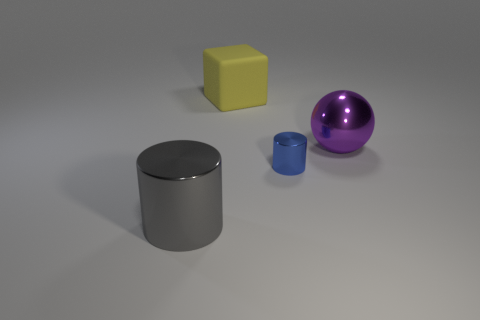Subtract all blue cylinders. How many cylinders are left? 1 Add 2 big yellow rubber objects. How many objects exist? 6 Subtract 0 brown blocks. How many objects are left? 4 Subtract all spheres. How many objects are left? 3 Subtract all gray cylinders. Subtract all green blocks. How many cylinders are left? 1 Subtract all purple spheres. How many blue cylinders are left? 1 Subtract all large yellow blocks. Subtract all big gray things. How many objects are left? 2 Add 1 blue cylinders. How many blue cylinders are left? 2 Add 4 blue objects. How many blue objects exist? 5 